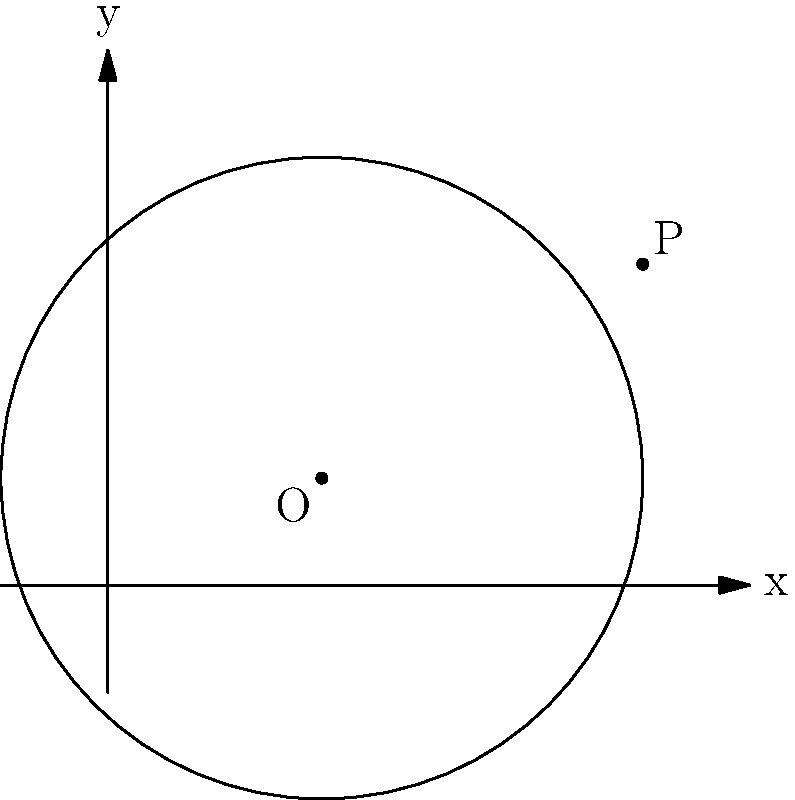In your latest novel, you've crafted a plot that follows a circular structure, mirroring the cyclical nature of life. To represent this mathematically, consider a circle with its center at point O(2,1) and a point P(5,3) on its circumference. Determine the equation of this circle, which symbolizes the journey of your protagonist through the story's cyclical plot. To find the equation of the circle, we'll follow these steps:

1) The general equation of a circle is $(x-h)^2 + (y-k)^2 = r^2$, where (h,k) is the center and r is the radius.

2) We're given the center O(2,1), so h=2 and k=1.

3) To find r, we need to calculate the distance between O(2,1) and P(5,3):

   $r^2 = (x_P - x_O)^2 + (y_P - y_O)^2$
   $r^2 = (5-2)^2 + (3-1)^2$
   $r^2 = 3^2 + 2^2 = 9 + 4 = 13$

4) Now we have all the components to write the equation:

   $(x-2)^2 + (y-1)^2 = 13$

This equation represents the circular journey of your protagonist, with the center (2,1) symbolizing a central theme or starting point, and the radius $\sqrt{13}$ representing the extent of the character's growth or the story's scope.
Answer: $(x-2)^2 + (y-1)^2 = 13$ 